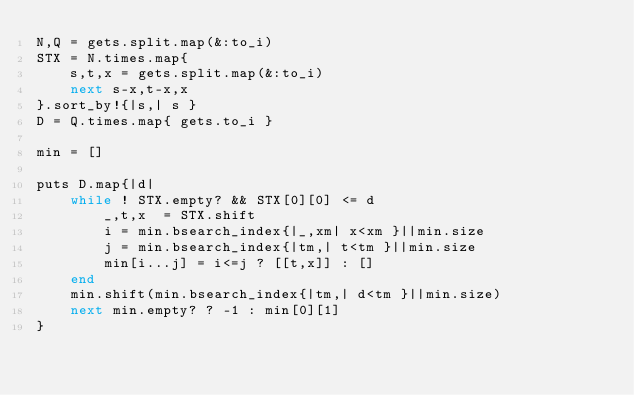<code> <loc_0><loc_0><loc_500><loc_500><_Ruby_>N,Q = gets.split.map(&:to_i)
STX = N.times.map{
	s,t,x = gets.split.map(&:to_i)
	next s-x,t-x,x
}.sort_by!{|s,| s }
D = Q.times.map{ gets.to_i }

min = []

puts D.map{|d|
	while ! STX.empty? && STX[0][0] <= d
		_,t,x  = STX.shift
		i = min.bsearch_index{|_,xm| x<xm }||min.size
		j = min.bsearch_index{|tm,| t<tm }||min.size
		min[i...j] = i<=j ? [[t,x]] : []
	end
	min.shift(min.bsearch_index{|tm,| d<tm }||min.size)
	next min.empty? ? -1 : min[0][1]
}
</code> 